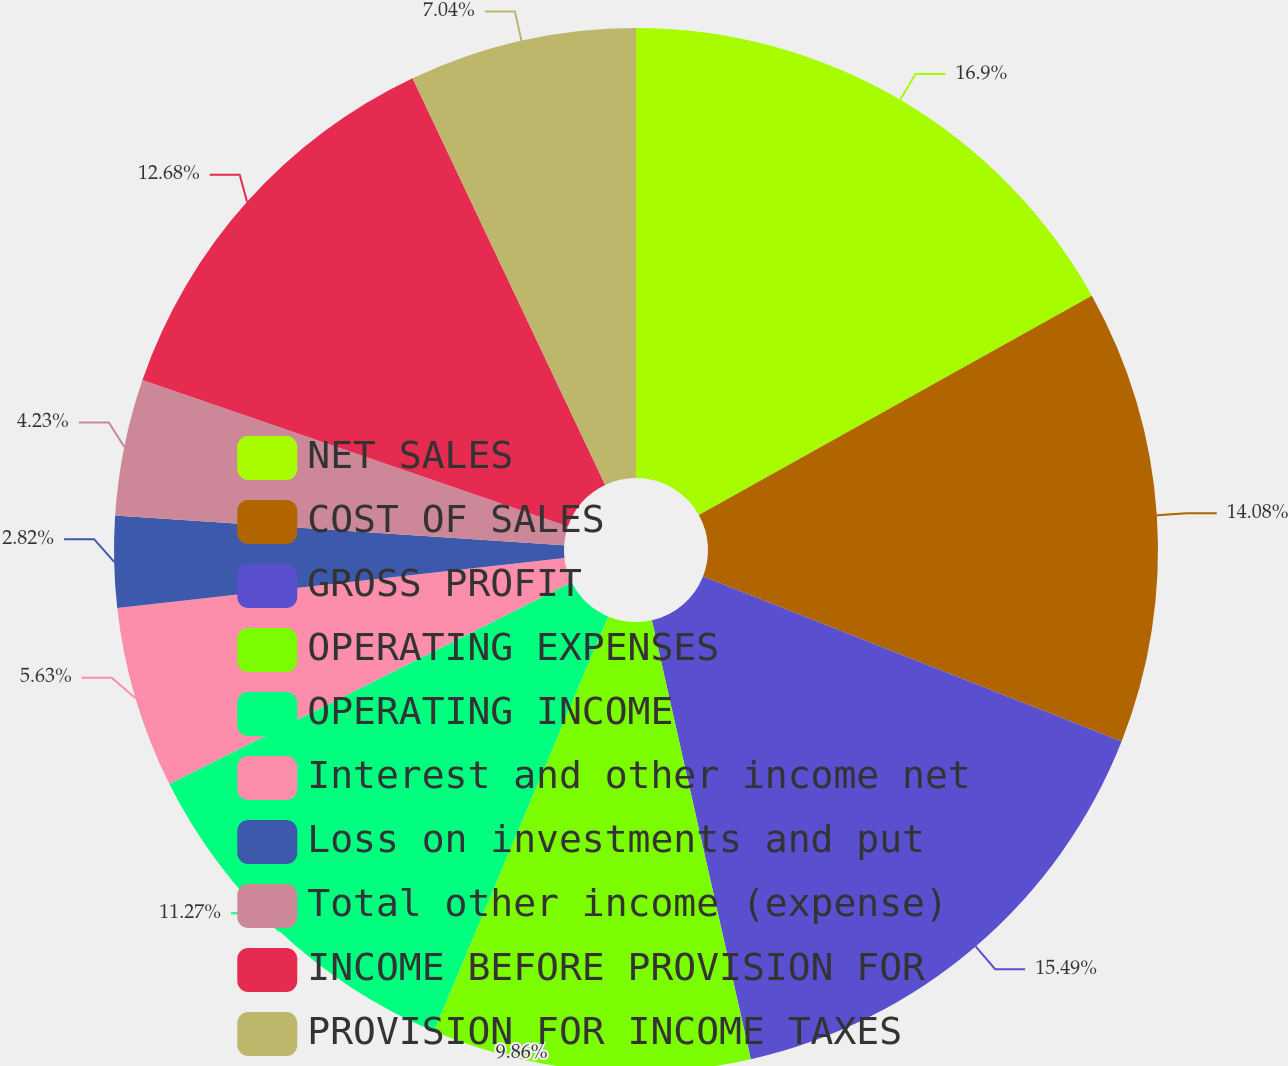Convert chart. <chart><loc_0><loc_0><loc_500><loc_500><pie_chart><fcel>NET SALES<fcel>COST OF SALES<fcel>GROSS PROFIT<fcel>OPERATING EXPENSES<fcel>OPERATING INCOME<fcel>Interest and other income net<fcel>Loss on investments and put<fcel>Total other income (expense)<fcel>INCOME BEFORE PROVISION FOR<fcel>PROVISION FOR INCOME TAXES<nl><fcel>16.9%<fcel>14.08%<fcel>15.49%<fcel>9.86%<fcel>11.27%<fcel>5.63%<fcel>2.82%<fcel>4.23%<fcel>12.68%<fcel>7.04%<nl></chart> 